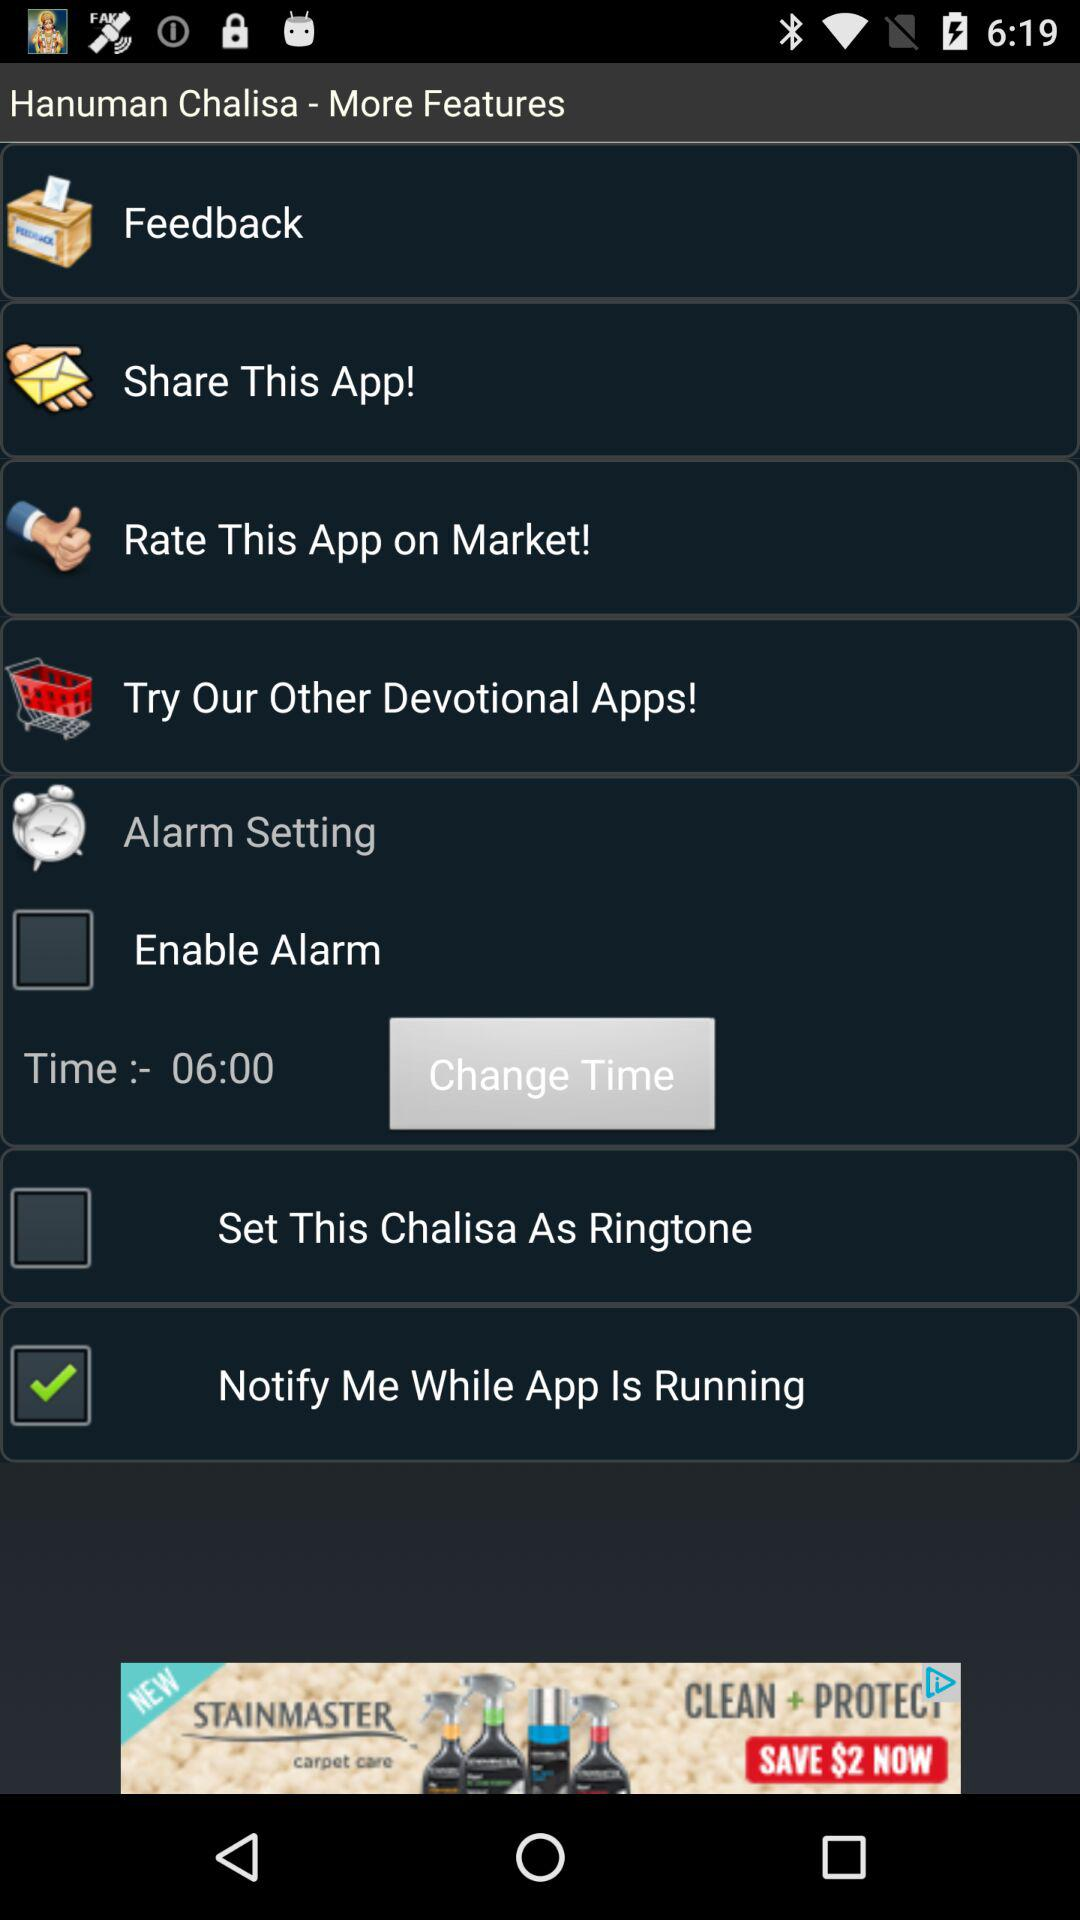What is the status of the "Notify Me While App Is Running"? The status is "on". 